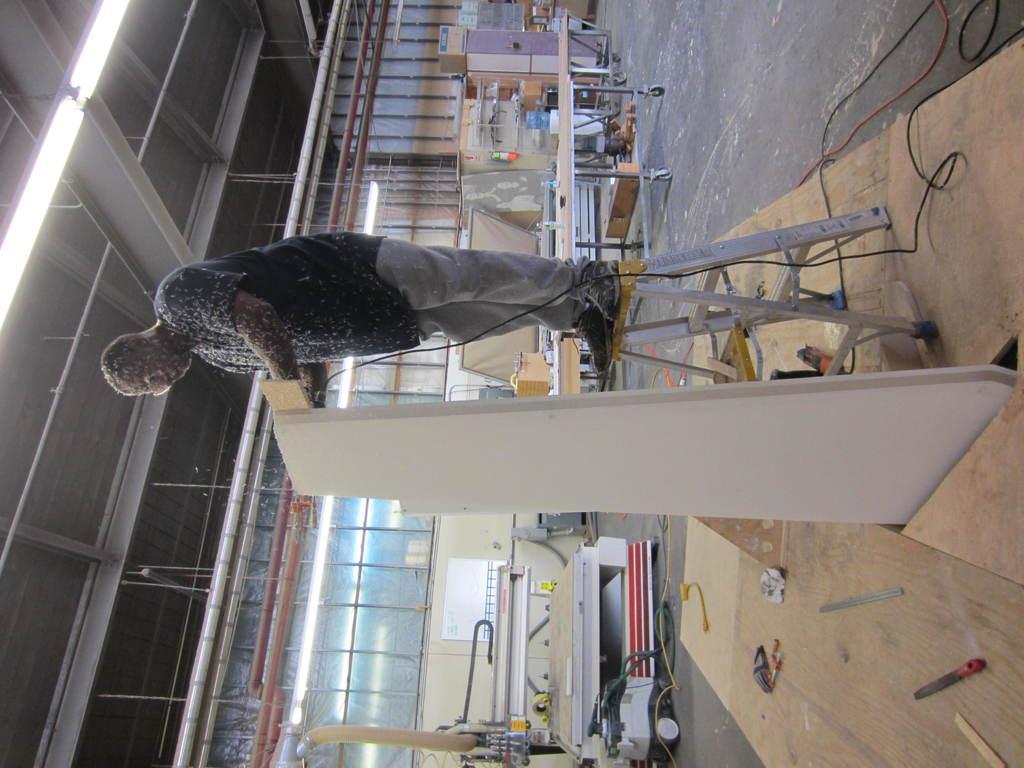How would you summarize this image in a sentence or two? In this image a person is standing on the ladder. He is holding a board. Few tables and few machines are on the floor. Left top there are few lights attached to the roof. 